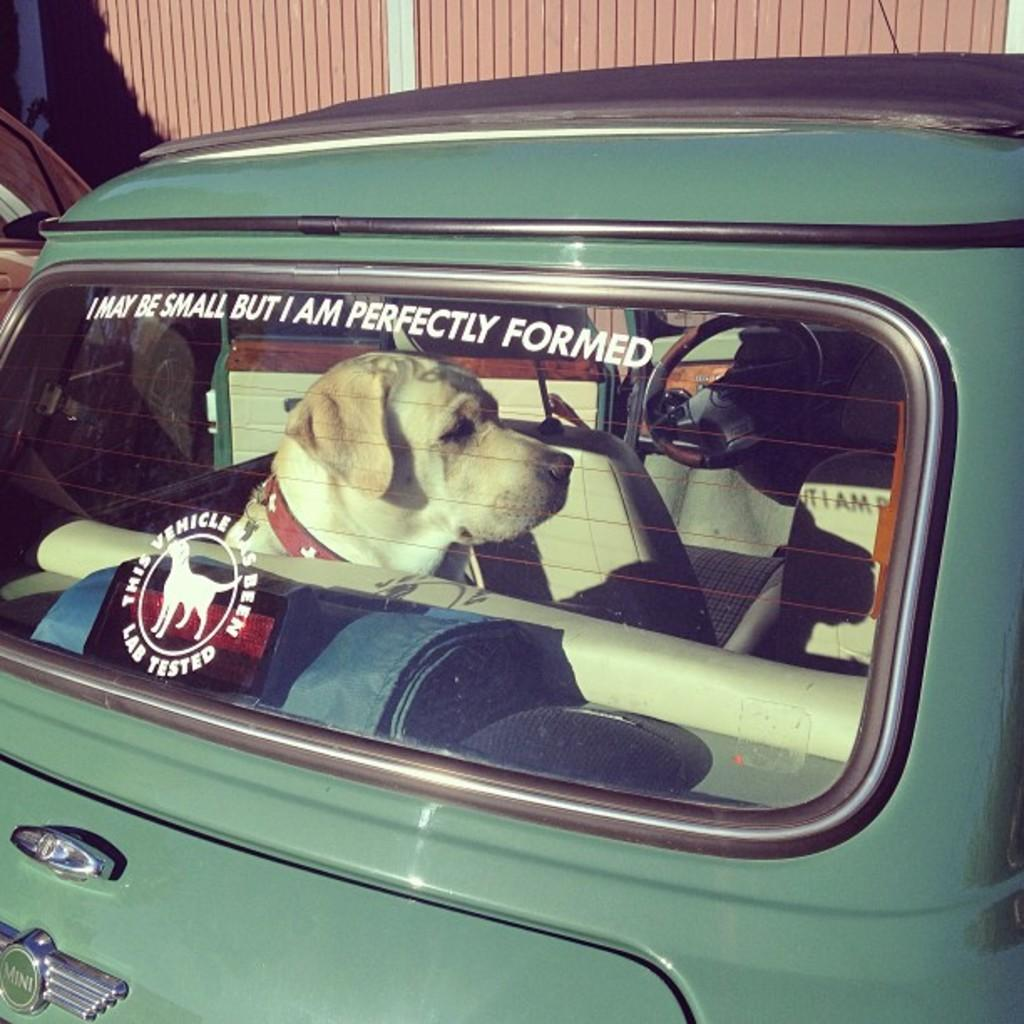What color is the car in the image? The car in the image is green. What can be seen inside the car? There is a dog inside the car, as well as seats and a steering wheel. What is visible in the background of the image? There is a fencing wall in the background of the image. What type of harmony is being played by the dog in the car? There is no indication in the image that the dog is playing any type of harmony, as dogs do not play musical instruments. 